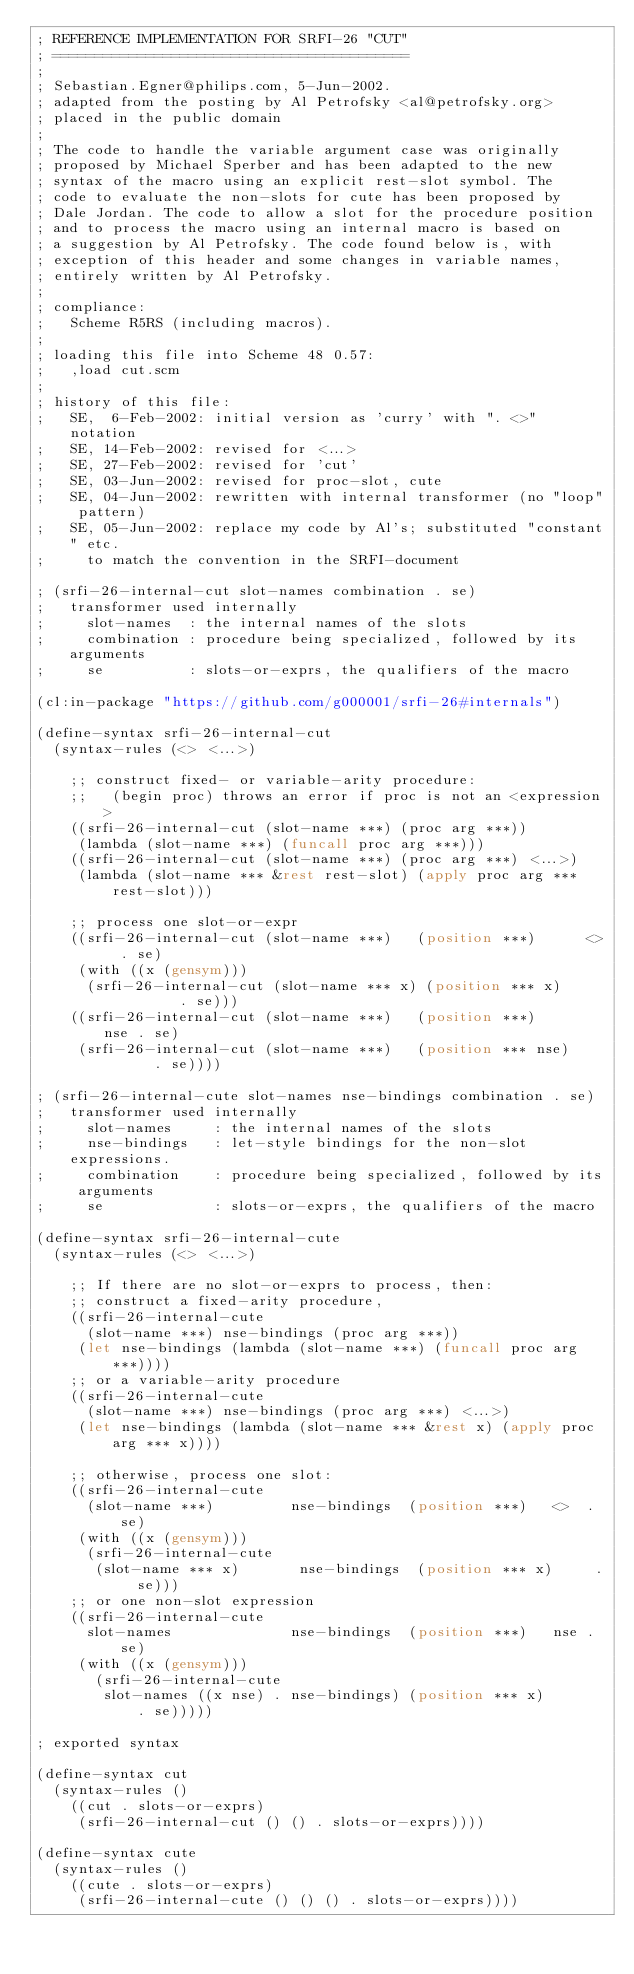Convert code to text. <code><loc_0><loc_0><loc_500><loc_500><_Lisp_>; REFERENCE IMPLEMENTATION FOR SRFI-26 "CUT"
; ==========================================
;
; Sebastian.Egner@philips.com, 5-Jun-2002.
; adapted from the posting by Al Petrofsky <al@petrofsky.org>
; placed in the public domain
;
; The code to handle the variable argument case was originally
; proposed by Michael Sperber and has been adapted to the new
; syntax of the macro using an explicit rest-slot symbol. The
; code to evaluate the non-slots for cute has been proposed by
; Dale Jordan. The code to allow a slot for the procedure position
; and to process the macro using an internal macro is based on
; a suggestion by Al Petrofsky. The code found below is, with
; exception of this header and some changes in variable names,
; entirely written by Al Petrofsky.
;
; compliance:
;   Scheme R5RS (including macros).
;
; loading this file into Scheme 48 0.57:
;   ,load cut.scm
;
; history of this file:
;   SE,  6-Feb-2002: initial version as 'curry' with ". <>" notation
;   SE, 14-Feb-2002: revised for <...>
;   SE, 27-Feb-2002: revised for 'cut'
;   SE, 03-Jun-2002: revised for proc-slot, cute
;   SE, 04-Jun-2002: rewritten with internal transformer (no "loop" pattern)
;   SE, 05-Jun-2002: replace my code by Al's; substituted "constant" etc.
;     to match the convention in the SRFI-document

; (srfi-26-internal-cut slot-names combination . se)
;   transformer used internally
;     slot-names  : the internal names of the slots
;     combination : procedure being specialized, followed by its arguments
;     se          : slots-or-exprs, the qualifiers of the macro

(cl:in-package "https://github.com/g000001/srfi-26#internals")

(define-syntax srfi-26-internal-cut
  (syntax-rules (<> <...>)

    ;; construct fixed- or variable-arity procedure:
    ;;   (begin proc) throws an error if proc is not an <expression>
    ((srfi-26-internal-cut (slot-name ***) (proc arg ***))
     (lambda (slot-name ***) (funcall proc arg ***)))
    ((srfi-26-internal-cut (slot-name ***) (proc arg ***) <...>)
     (lambda (slot-name *** &rest rest-slot) (apply proc arg *** rest-slot)))

    ;; process one slot-or-expr
    ((srfi-26-internal-cut (slot-name ***)   (position ***)      <>  . se)
     (with ((x (gensym)))
      (srfi-26-internal-cut (slot-name *** x) (position *** x)        . se)))
    ((srfi-26-internal-cut (slot-name ***)   (position ***)      nse . se)
     (srfi-26-internal-cut (slot-name ***)   (position *** nse)      . se))))

; (srfi-26-internal-cute slot-names nse-bindings combination . se)
;   transformer used internally
;     slot-names     : the internal names of the slots
;     nse-bindings   : let-style bindings for the non-slot expressions.
;     combination    : procedure being specialized, followed by its arguments
;     se             : slots-or-exprs, the qualifiers of the macro

(define-syntax srfi-26-internal-cute
  (syntax-rules (<> <...>)

    ;; If there are no slot-or-exprs to process, then:
    ;; construct a fixed-arity procedure,
    ((srfi-26-internal-cute
      (slot-name ***) nse-bindings (proc arg ***))
     (let nse-bindings (lambda (slot-name ***) (funcall proc arg ***))))
    ;; or a variable-arity procedure
    ((srfi-26-internal-cute
      (slot-name ***) nse-bindings (proc arg ***) <...>)
     (let nse-bindings (lambda (slot-name *** &rest x) (apply proc arg *** x))))

    ;; otherwise, process one slot:
    ((srfi-26-internal-cute
      (slot-name ***)         nse-bindings  (position ***)   <>  . se)
     (with ((x (gensym)))
      (srfi-26-internal-cute
       (slot-name *** x)       nse-bindings  (position *** x)     . se)))
    ;; or one non-slot expression
    ((srfi-26-internal-cute
      slot-names              nse-bindings  (position ***)   nse . se)
     (with ((x (gensym)))
       (srfi-26-internal-cute
        slot-names ((x nse) . nse-bindings) (position *** x)       . se)))))

; exported syntax

(define-syntax cut
  (syntax-rules ()
    ((cut . slots-or-exprs)
     (srfi-26-internal-cut () () . slots-or-exprs))))

(define-syntax cute
  (syntax-rules ()
    ((cute . slots-or-exprs)
     (srfi-26-internal-cute () () () . slots-or-exprs))))
</code> 